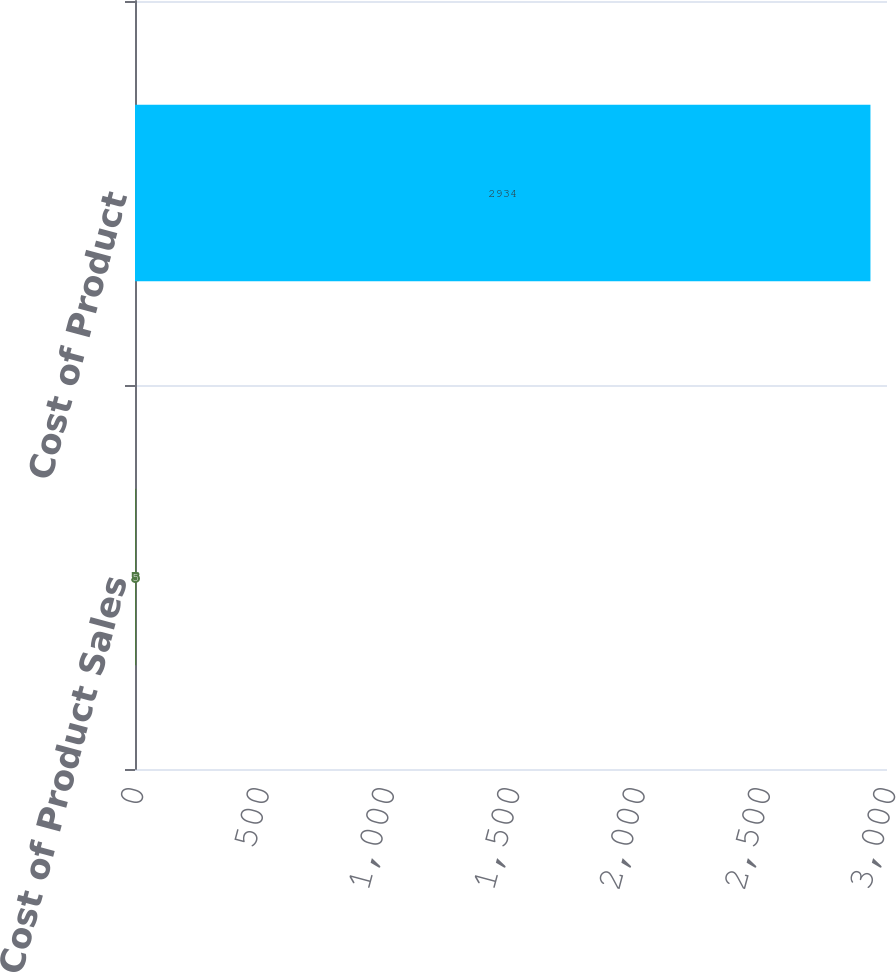Convert chart. <chart><loc_0><loc_0><loc_500><loc_500><bar_chart><fcel>Cost of Product Sales<fcel>Cost of Product<nl><fcel>5<fcel>2934<nl></chart> 